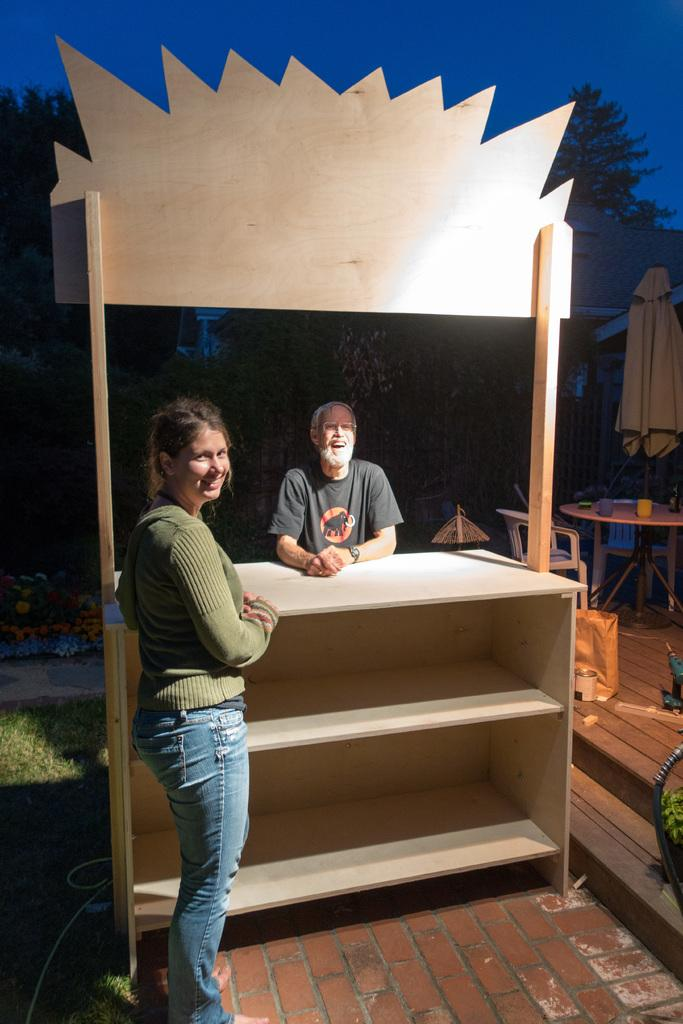How many people are in the image? There is a woman and a man in the image. What are the woman and man doing in the image? The woman and man are standing. What can be seen in the background of the image? There is a table, chairs, a tent, trees, and the sky visible in the background of the image. How many centimeters long is the wrist of the woman in the image? There is no information about the wrist size of the woman in the image, and therefore it cannot be determined. 